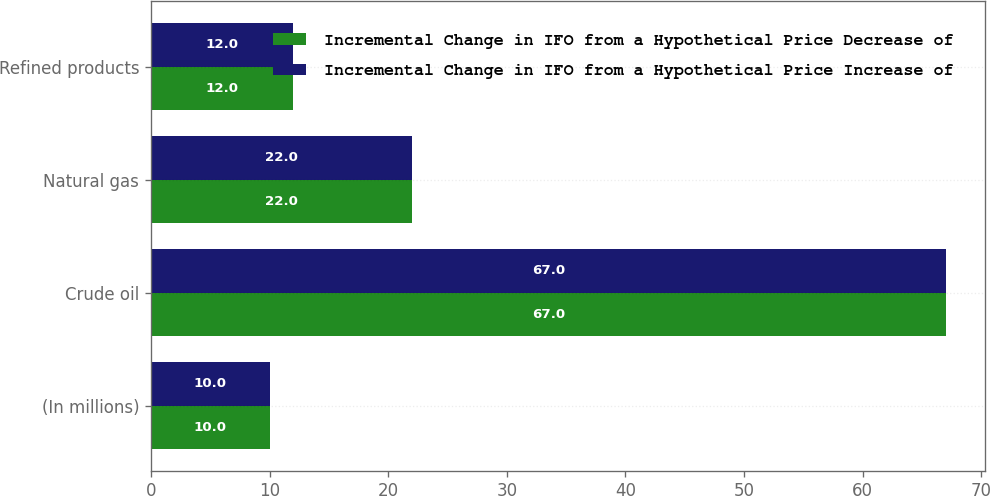<chart> <loc_0><loc_0><loc_500><loc_500><stacked_bar_chart><ecel><fcel>(In millions)<fcel>Crude oil<fcel>Natural gas<fcel>Refined products<nl><fcel>Incremental Change in IFO from a Hypothetical Price Decrease of<fcel>10<fcel>67<fcel>22<fcel>12<nl><fcel>Incremental Change in IFO from a Hypothetical Price Increase of<fcel>10<fcel>67<fcel>22<fcel>12<nl></chart> 